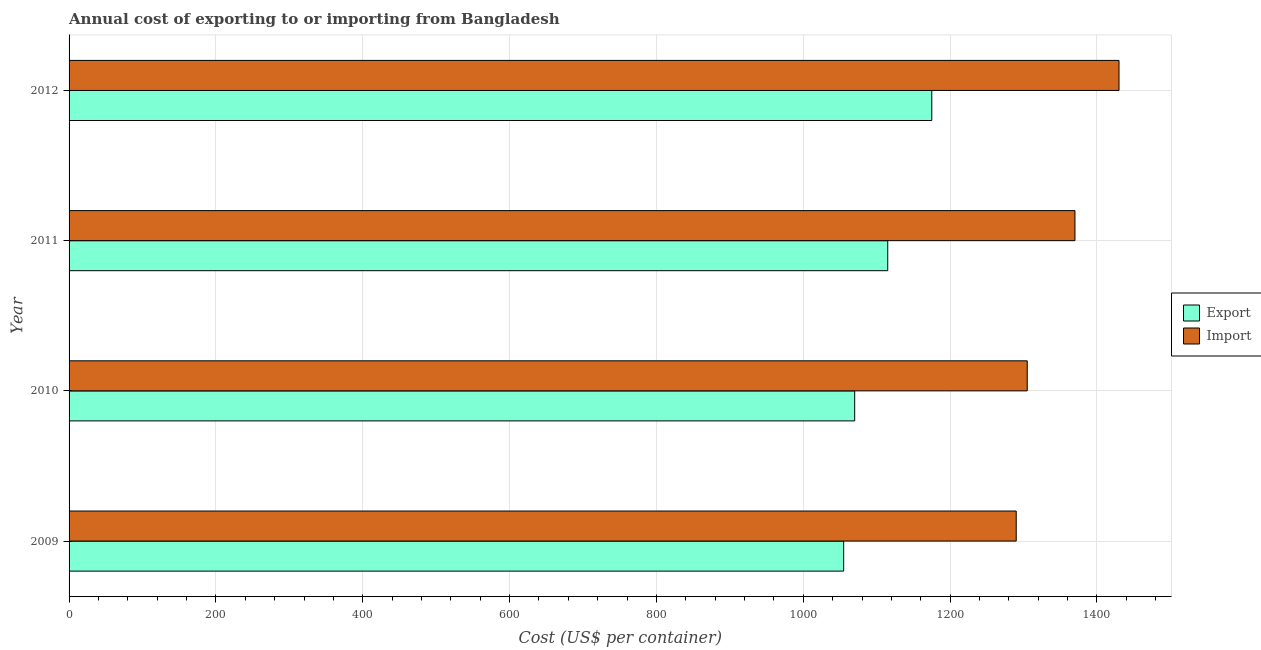How many groups of bars are there?
Ensure brevity in your answer.  4. Are the number of bars per tick equal to the number of legend labels?
Provide a succinct answer. Yes. Are the number of bars on each tick of the Y-axis equal?
Offer a very short reply. Yes. How many bars are there on the 3rd tick from the bottom?
Give a very brief answer. 2. What is the import cost in 2010?
Provide a short and direct response. 1305. Across all years, what is the maximum import cost?
Offer a terse response. 1430. Across all years, what is the minimum import cost?
Offer a terse response. 1290. What is the total import cost in the graph?
Give a very brief answer. 5395. What is the difference between the import cost in 2010 and that in 2012?
Your answer should be compact. -125. What is the difference between the import cost in 2011 and the export cost in 2009?
Provide a short and direct response. 315. What is the average export cost per year?
Offer a very short reply. 1103.75. In the year 2009, what is the difference between the export cost and import cost?
Your response must be concise. -235. In how many years, is the import cost greater than 520 US$?
Your answer should be very brief. 4. What is the ratio of the export cost in 2009 to that in 2012?
Offer a very short reply. 0.9. Is the export cost in 2009 less than that in 2012?
Your answer should be compact. Yes. Is the difference between the import cost in 2010 and 2012 greater than the difference between the export cost in 2010 and 2012?
Provide a succinct answer. No. What is the difference between the highest and the lowest export cost?
Give a very brief answer. 120. Is the sum of the export cost in 2009 and 2011 greater than the maximum import cost across all years?
Make the answer very short. Yes. What does the 2nd bar from the top in 2012 represents?
Make the answer very short. Export. What does the 1st bar from the bottom in 2009 represents?
Offer a terse response. Export. How many bars are there?
Give a very brief answer. 8. Are all the bars in the graph horizontal?
Your response must be concise. Yes. How many years are there in the graph?
Your answer should be compact. 4. Are the values on the major ticks of X-axis written in scientific E-notation?
Your response must be concise. No. Does the graph contain any zero values?
Ensure brevity in your answer.  No. Where does the legend appear in the graph?
Your response must be concise. Center right. How are the legend labels stacked?
Your answer should be compact. Vertical. What is the title of the graph?
Give a very brief answer. Annual cost of exporting to or importing from Bangladesh. What is the label or title of the X-axis?
Provide a short and direct response. Cost (US$ per container). What is the Cost (US$ per container) of Export in 2009?
Provide a short and direct response. 1055. What is the Cost (US$ per container) in Import in 2009?
Your answer should be very brief. 1290. What is the Cost (US$ per container) in Export in 2010?
Your answer should be compact. 1070. What is the Cost (US$ per container) of Import in 2010?
Make the answer very short. 1305. What is the Cost (US$ per container) in Export in 2011?
Your answer should be compact. 1115. What is the Cost (US$ per container) of Import in 2011?
Your answer should be very brief. 1370. What is the Cost (US$ per container) in Export in 2012?
Ensure brevity in your answer.  1175. What is the Cost (US$ per container) in Import in 2012?
Offer a very short reply. 1430. Across all years, what is the maximum Cost (US$ per container) in Export?
Ensure brevity in your answer.  1175. Across all years, what is the maximum Cost (US$ per container) of Import?
Offer a very short reply. 1430. Across all years, what is the minimum Cost (US$ per container) of Export?
Your response must be concise. 1055. Across all years, what is the minimum Cost (US$ per container) in Import?
Make the answer very short. 1290. What is the total Cost (US$ per container) of Export in the graph?
Keep it short and to the point. 4415. What is the total Cost (US$ per container) in Import in the graph?
Your response must be concise. 5395. What is the difference between the Cost (US$ per container) of Import in 2009 and that in 2010?
Give a very brief answer. -15. What is the difference between the Cost (US$ per container) in Export in 2009 and that in 2011?
Offer a terse response. -60. What is the difference between the Cost (US$ per container) of Import in 2009 and that in 2011?
Provide a short and direct response. -80. What is the difference between the Cost (US$ per container) in Export in 2009 and that in 2012?
Make the answer very short. -120. What is the difference between the Cost (US$ per container) of Import in 2009 and that in 2012?
Ensure brevity in your answer.  -140. What is the difference between the Cost (US$ per container) in Export in 2010 and that in 2011?
Provide a short and direct response. -45. What is the difference between the Cost (US$ per container) in Import in 2010 and that in 2011?
Your response must be concise. -65. What is the difference between the Cost (US$ per container) of Export in 2010 and that in 2012?
Provide a succinct answer. -105. What is the difference between the Cost (US$ per container) of Import in 2010 and that in 2012?
Provide a succinct answer. -125. What is the difference between the Cost (US$ per container) of Export in 2011 and that in 2012?
Provide a short and direct response. -60. What is the difference between the Cost (US$ per container) in Import in 2011 and that in 2012?
Your answer should be compact. -60. What is the difference between the Cost (US$ per container) in Export in 2009 and the Cost (US$ per container) in Import in 2010?
Keep it short and to the point. -250. What is the difference between the Cost (US$ per container) in Export in 2009 and the Cost (US$ per container) in Import in 2011?
Offer a very short reply. -315. What is the difference between the Cost (US$ per container) in Export in 2009 and the Cost (US$ per container) in Import in 2012?
Your answer should be compact. -375. What is the difference between the Cost (US$ per container) in Export in 2010 and the Cost (US$ per container) in Import in 2011?
Make the answer very short. -300. What is the difference between the Cost (US$ per container) in Export in 2010 and the Cost (US$ per container) in Import in 2012?
Your response must be concise. -360. What is the difference between the Cost (US$ per container) in Export in 2011 and the Cost (US$ per container) in Import in 2012?
Ensure brevity in your answer.  -315. What is the average Cost (US$ per container) of Export per year?
Your response must be concise. 1103.75. What is the average Cost (US$ per container) in Import per year?
Ensure brevity in your answer.  1348.75. In the year 2009, what is the difference between the Cost (US$ per container) in Export and Cost (US$ per container) in Import?
Your answer should be compact. -235. In the year 2010, what is the difference between the Cost (US$ per container) of Export and Cost (US$ per container) of Import?
Keep it short and to the point. -235. In the year 2011, what is the difference between the Cost (US$ per container) in Export and Cost (US$ per container) in Import?
Offer a very short reply. -255. In the year 2012, what is the difference between the Cost (US$ per container) of Export and Cost (US$ per container) of Import?
Your answer should be very brief. -255. What is the ratio of the Cost (US$ per container) in Export in 2009 to that in 2011?
Offer a terse response. 0.95. What is the ratio of the Cost (US$ per container) in Import in 2009 to that in 2011?
Keep it short and to the point. 0.94. What is the ratio of the Cost (US$ per container) in Export in 2009 to that in 2012?
Your answer should be compact. 0.9. What is the ratio of the Cost (US$ per container) in Import in 2009 to that in 2012?
Your answer should be compact. 0.9. What is the ratio of the Cost (US$ per container) in Export in 2010 to that in 2011?
Your response must be concise. 0.96. What is the ratio of the Cost (US$ per container) in Import in 2010 to that in 2011?
Provide a succinct answer. 0.95. What is the ratio of the Cost (US$ per container) of Export in 2010 to that in 2012?
Give a very brief answer. 0.91. What is the ratio of the Cost (US$ per container) in Import in 2010 to that in 2012?
Keep it short and to the point. 0.91. What is the ratio of the Cost (US$ per container) in Export in 2011 to that in 2012?
Make the answer very short. 0.95. What is the ratio of the Cost (US$ per container) of Import in 2011 to that in 2012?
Keep it short and to the point. 0.96. What is the difference between the highest and the second highest Cost (US$ per container) in Export?
Your answer should be compact. 60. What is the difference between the highest and the second highest Cost (US$ per container) of Import?
Provide a short and direct response. 60. What is the difference between the highest and the lowest Cost (US$ per container) in Export?
Give a very brief answer. 120. What is the difference between the highest and the lowest Cost (US$ per container) of Import?
Keep it short and to the point. 140. 